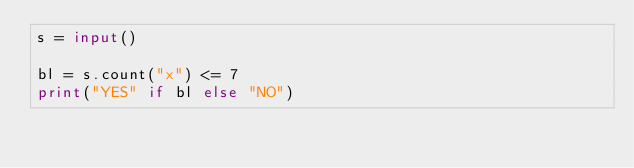<code> <loc_0><loc_0><loc_500><loc_500><_Python_>s = input()

bl = s.count("x") <= 7
print("YES" if bl else "NO")
</code> 